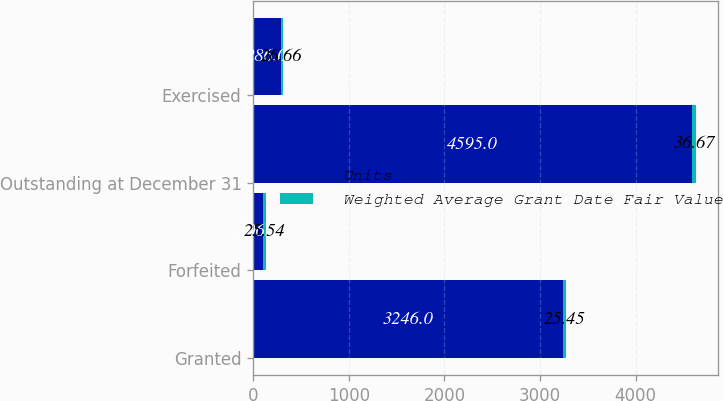<chart> <loc_0><loc_0><loc_500><loc_500><stacked_bar_chart><ecel><fcel>Granted<fcel>Forfeited<fcel>Outstanding at December 31<fcel>Exercised<nl><fcel>Units<fcel>3246<fcel>106<fcel>4595<fcel>286<nl><fcel>Weighted Average Grant Date Fair Value<fcel>25.45<fcel>25.54<fcel>36.67<fcel>26.66<nl></chart> 